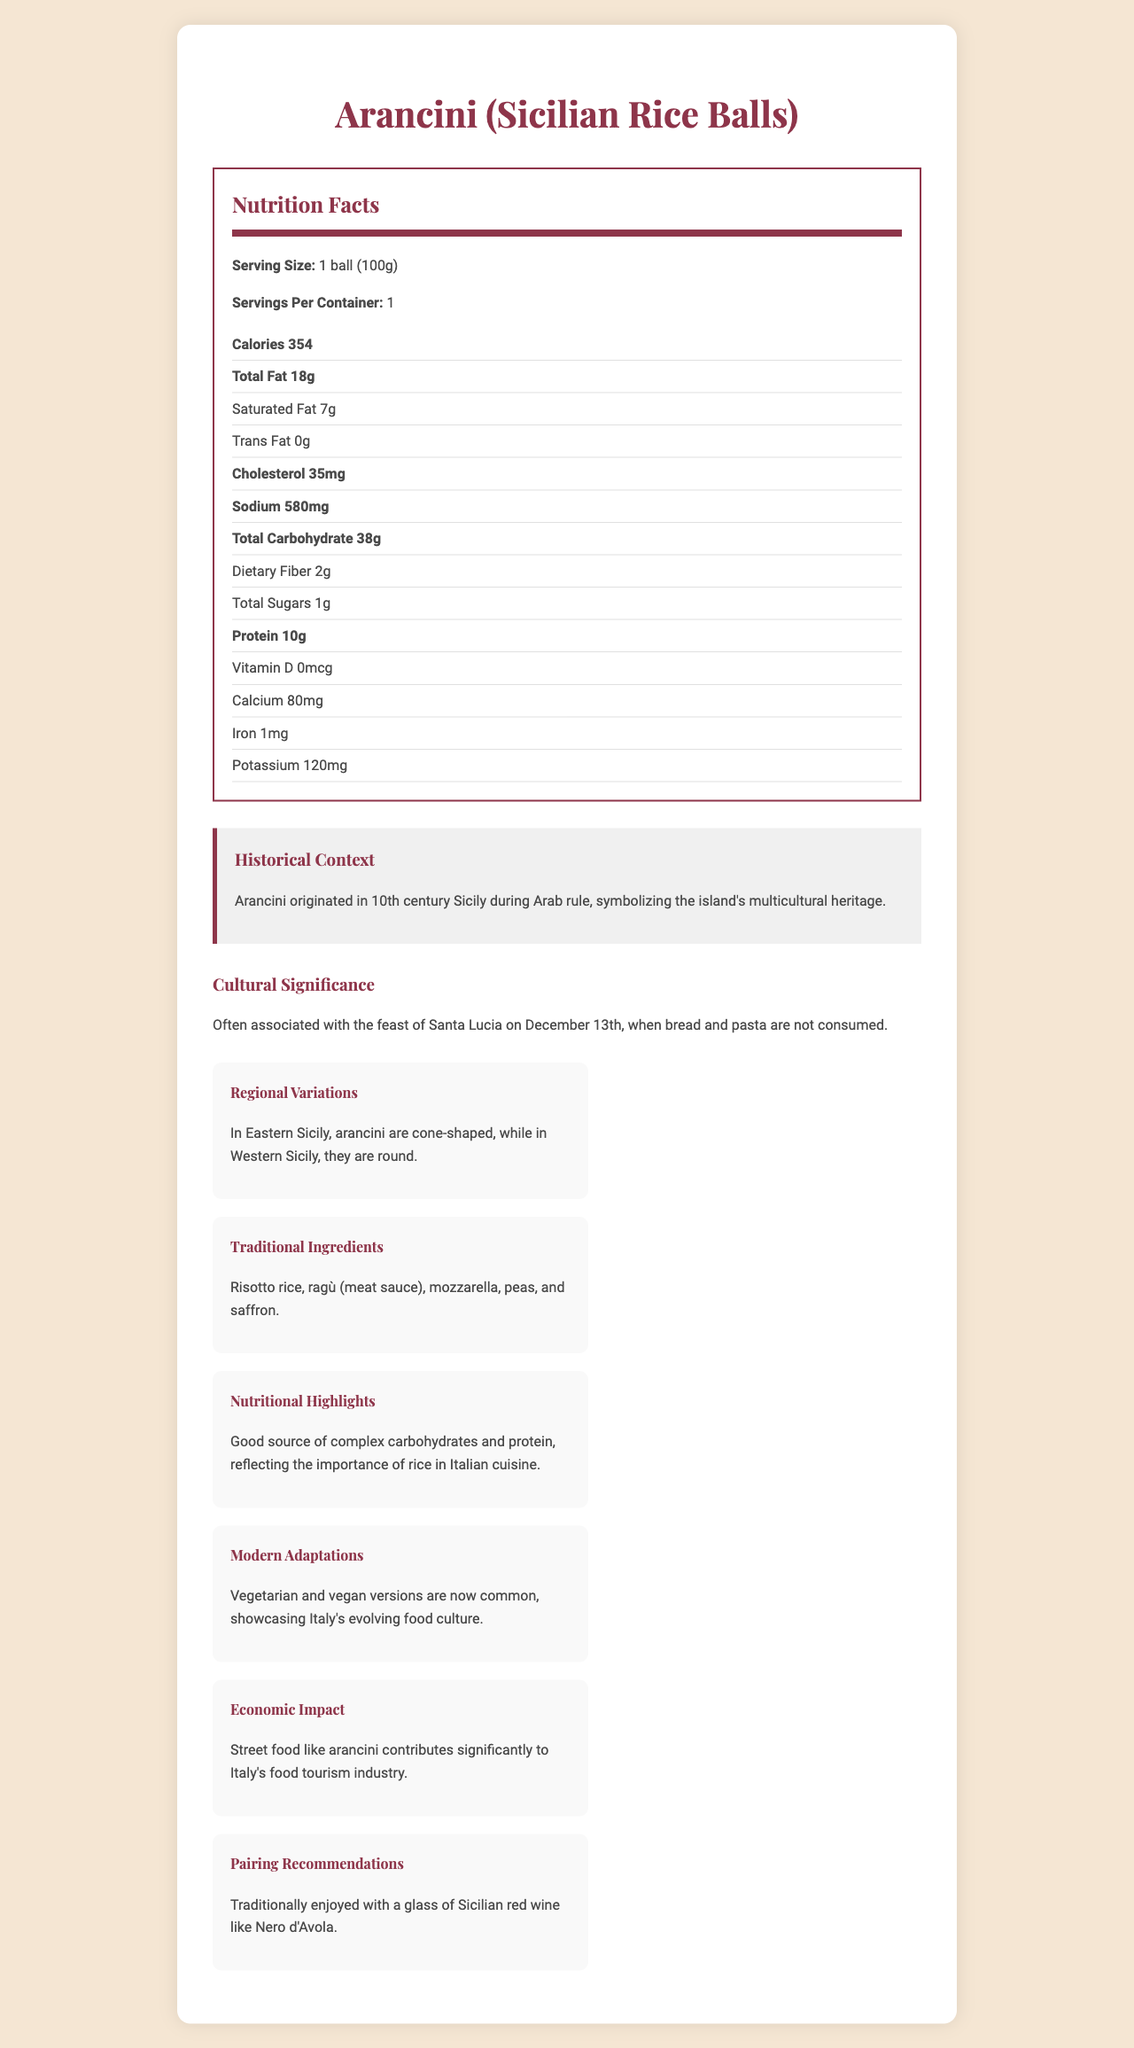what is the serving size of Arancini? The serving size is clearly stated as "1 ball (100g)" under the Nutrition Facts section.
Answer: 1 ball (100g) what is the calorie count per serving? The document states that the calorie count per serving is 354.
Answer: 354 how much total fat does one serving contain? The total fat content per serving is listed as 18g in the nutrition table.
Answer: 18g what are the traditional ingredients used in Arancini? This information is listed under the "Traditional Ingredients" section.
Answer: Risotto rice, ragù (meat sauce), mozzarella, peas, and saffron how much sodium is there in one serving of Arancini? The sodium content for one serving is given as 580mg in the nutrition table.
Answer: 580mg is trans fat present in Arancini? The nutrition table indicates that the trans fat content is 0g, which means there is no trans fat present.
Answer: No how is Arancini traditionally shaped in eastern and western Sicily? A. Round in both regions B. Cone-shaped in the East and round in the West C. Cone-shaped in the West and round in the East The document notes that in Eastern Sicily, Arancini are cone-shaped, while in Western Sicily, they are round.
Answer: B which holiday is Arancini associated with? A. Christmas B. Easter C. Feast of Santa Lucia The cultural significance section mentions that Arancini is associated with the feast of Santa Lucia on December 13th.
Answer: C do Arancini contain any dietary fiber? The nutrition facts state that there are 2g of dietary fiber per serving.
Answer: Yes how has modern Italian cuisine adapted the traditional Arancini recipe? The document notes that modern adaptations include vegetarian and vegan versions, highlighting Italy's evolving food culture.
Answer: Vegetarian and vegan versions what is a traditional pairing recommendation for Arancini? The pairing recommendation section suggests enjoying Arancini with a glass of Sicilian red wine such as Nero d'Avola.
Answer: Sicilian red wine like Nero d'Avola summarize the document about Arancini The document offers comprehensive insight into Arancini, covering aspects from its nutrition facts to its historical and cultural background, as well as its impact on food tourism in Italy.
Answer: The document provides detailed nutritional information, historical context, cultural significance, regional variations, traditional ingredients, modern adaptations, economic impact, and pairing recommendations for Arancini (Sicilian Rice Balls). what is the impact of Arancini on Italy's food tourism industry? The economic impact section states that street food like Arancini contributes significantly to Italy's food tourism industry.
Answer: Significant contribution what is the role of Arab rule in the history of Arancini? The historical context section indicates that Arancini originated during 10th century Sicily under Arab rule, symbolizing Sicily's multicultural heritage.
Answer: Symbolizes the island's multicultural heritage what is the calcium content in one serving of Arancini? The nutrition facts table lists the calcium content as 80mg per serving.
Answer: 80mg does one serving of Arancini contain iron? The nutrition facts table lists iron content as 1mg per serving.
Answer: Yes, 1mg can we determine the price of Arancini from the document? The document provides nutritional and cultural details but does not include any information about pricing.
Answer: Not enough information 